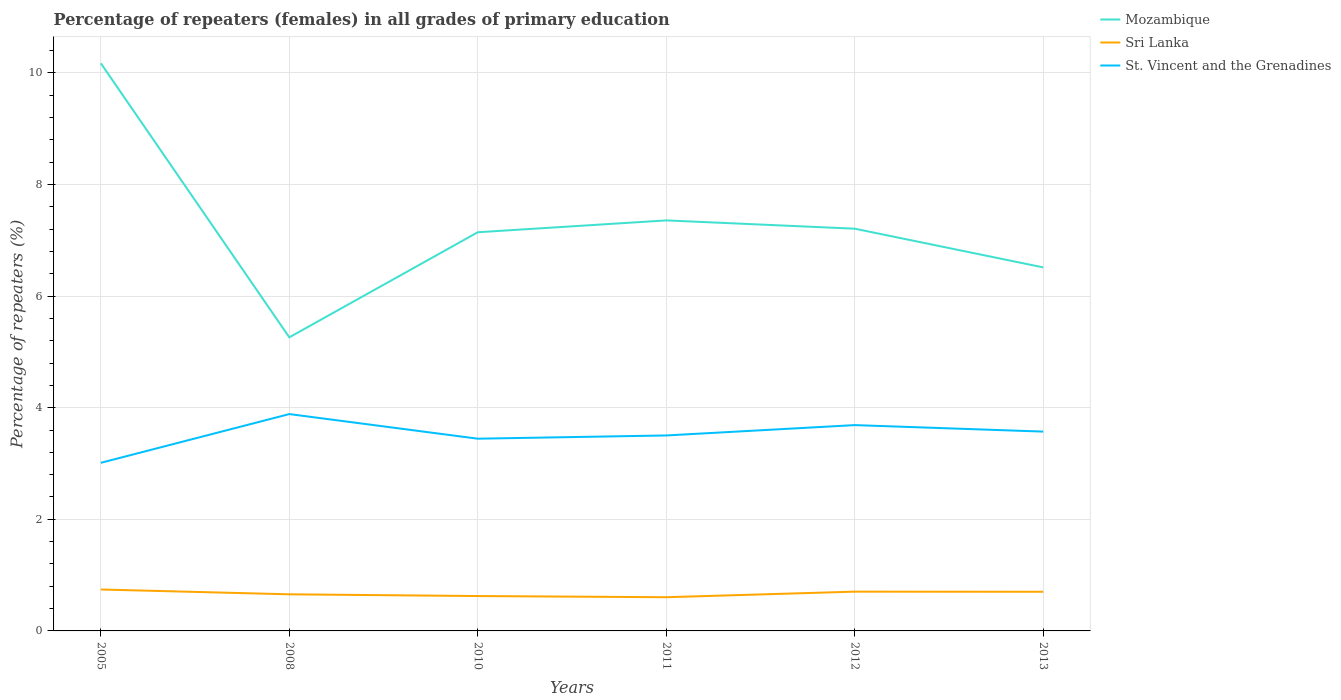How many different coloured lines are there?
Provide a succinct answer. 3. Is the number of lines equal to the number of legend labels?
Your answer should be very brief. Yes. Across all years, what is the maximum percentage of repeaters (females) in Mozambique?
Keep it short and to the point. 5.26. What is the total percentage of repeaters (females) in St. Vincent and the Grenadines in the graph?
Keep it short and to the point. -0.24. What is the difference between the highest and the second highest percentage of repeaters (females) in Mozambique?
Make the answer very short. 4.91. What is the difference between the highest and the lowest percentage of repeaters (females) in Sri Lanka?
Provide a short and direct response. 3. How many lines are there?
Make the answer very short. 3. What is the difference between two consecutive major ticks on the Y-axis?
Your answer should be compact. 2. Does the graph contain any zero values?
Keep it short and to the point. No. Does the graph contain grids?
Keep it short and to the point. Yes. Where does the legend appear in the graph?
Give a very brief answer. Top right. How many legend labels are there?
Your response must be concise. 3. What is the title of the graph?
Ensure brevity in your answer.  Percentage of repeaters (females) in all grades of primary education. Does "Belize" appear as one of the legend labels in the graph?
Make the answer very short. No. What is the label or title of the Y-axis?
Your answer should be compact. Percentage of repeaters (%). What is the Percentage of repeaters (%) of Mozambique in 2005?
Your answer should be compact. 10.17. What is the Percentage of repeaters (%) of Sri Lanka in 2005?
Keep it short and to the point. 0.74. What is the Percentage of repeaters (%) of St. Vincent and the Grenadines in 2005?
Your answer should be very brief. 3.01. What is the Percentage of repeaters (%) of Mozambique in 2008?
Offer a very short reply. 5.26. What is the Percentage of repeaters (%) of Sri Lanka in 2008?
Your answer should be compact. 0.66. What is the Percentage of repeaters (%) of St. Vincent and the Grenadines in 2008?
Provide a succinct answer. 3.89. What is the Percentage of repeaters (%) of Mozambique in 2010?
Keep it short and to the point. 7.14. What is the Percentage of repeaters (%) in Sri Lanka in 2010?
Keep it short and to the point. 0.63. What is the Percentage of repeaters (%) in St. Vincent and the Grenadines in 2010?
Your response must be concise. 3.44. What is the Percentage of repeaters (%) of Mozambique in 2011?
Your answer should be compact. 7.36. What is the Percentage of repeaters (%) of Sri Lanka in 2011?
Provide a succinct answer. 0.6. What is the Percentage of repeaters (%) in St. Vincent and the Grenadines in 2011?
Provide a short and direct response. 3.5. What is the Percentage of repeaters (%) of Mozambique in 2012?
Offer a very short reply. 7.21. What is the Percentage of repeaters (%) in Sri Lanka in 2012?
Make the answer very short. 0.7. What is the Percentage of repeaters (%) of St. Vincent and the Grenadines in 2012?
Ensure brevity in your answer.  3.69. What is the Percentage of repeaters (%) of Mozambique in 2013?
Give a very brief answer. 6.51. What is the Percentage of repeaters (%) in Sri Lanka in 2013?
Offer a terse response. 0.7. What is the Percentage of repeaters (%) of St. Vincent and the Grenadines in 2013?
Your response must be concise. 3.57. Across all years, what is the maximum Percentage of repeaters (%) in Mozambique?
Ensure brevity in your answer.  10.17. Across all years, what is the maximum Percentage of repeaters (%) in Sri Lanka?
Keep it short and to the point. 0.74. Across all years, what is the maximum Percentage of repeaters (%) in St. Vincent and the Grenadines?
Give a very brief answer. 3.89. Across all years, what is the minimum Percentage of repeaters (%) in Mozambique?
Give a very brief answer. 5.26. Across all years, what is the minimum Percentage of repeaters (%) of Sri Lanka?
Offer a very short reply. 0.6. Across all years, what is the minimum Percentage of repeaters (%) in St. Vincent and the Grenadines?
Provide a succinct answer. 3.01. What is the total Percentage of repeaters (%) in Mozambique in the graph?
Provide a succinct answer. 43.66. What is the total Percentage of repeaters (%) of Sri Lanka in the graph?
Your answer should be very brief. 4.03. What is the total Percentage of repeaters (%) in St. Vincent and the Grenadines in the graph?
Provide a short and direct response. 21.11. What is the difference between the Percentage of repeaters (%) of Mozambique in 2005 and that in 2008?
Keep it short and to the point. 4.91. What is the difference between the Percentage of repeaters (%) of Sri Lanka in 2005 and that in 2008?
Keep it short and to the point. 0.09. What is the difference between the Percentage of repeaters (%) in St. Vincent and the Grenadines in 2005 and that in 2008?
Ensure brevity in your answer.  -0.87. What is the difference between the Percentage of repeaters (%) in Mozambique in 2005 and that in 2010?
Your response must be concise. 3.03. What is the difference between the Percentage of repeaters (%) in Sri Lanka in 2005 and that in 2010?
Your answer should be very brief. 0.12. What is the difference between the Percentage of repeaters (%) in St. Vincent and the Grenadines in 2005 and that in 2010?
Provide a succinct answer. -0.43. What is the difference between the Percentage of repeaters (%) of Mozambique in 2005 and that in 2011?
Your answer should be compact. 2.82. What is the difference between the Percentage of repeaters (%) in Sri Lanka in 2005 and that in 2011?
Your answer should be compact. 0.14. What is the difference between the Percentage of repeaters (%) of St. Vincent and the Grenadines in 2005 and that in 2011?
Offer a terse response. -0.49. What is the difference between the Percentage of repeaters (%) in Mozambique in 2005 and that in 2012?
Provide a short and direct response. 2.96. What is the difference between the Percentage of repeaters (%) of Sri Lanka in 2005 and that in 2012?
Your answer should be compact. 0.04. What is the difference between the Percentage of repeaters (%) in St. Vincent and the Grenadines in 2005 and that in 2012?
Your response must be concise. -0.68. What is the difference between the Percentage of repeaters (%) in Mozambique in 2005 and that in 2013?
Make the answer very short. 3.66. What is the difference between the Percentage of repeaters (%) of Sri Lanka in 2005 and that in 2013?
Give a very brief answer. 0.04. What is the difference between the Percentage of repeaters (%) of St. Vincent and the Grenadines in 2005 and that in 2013?
Your answer should be compact. -0.56. What is the difference between the Percentage of repeaters (%) of Mozambique in 2008 and that in 2010?
Offer a very short reply. -1.88. What is the difference between the Percentage of repeaters (%) of Sri Lanka in 2008 and that in 2010?
Make the answer very short. 0.03. What is the difference between the Percentage of repeaters (%) in St. Vincent and the Grenadines in 2008 and that in 2010?
Offer a very short reply. 0.44. What is the difference between the Percentage of repeaters (%) of Mozambique in 2008 and that in 2011?
Give a very brief answer. -2.1. What is the difference between the Percentage of repeaters (%) in Sri Lanka in 2008 and that in 2011?
Your answer should be very brief. 0.05. What is the difference between the Percentage of repeaters (%) of St. Vincent and the Grenadines in 2008 and that in 2011?
Your response must be concise. 0.38. What is the difference between the Percentage of repeaters (%) of Mozambique in 2008 and that in 2012?
Give a very brief answer. -1.95. What is the difference between the Percentage of repeaters (%) of Sri Lanka in 2008 and that in 2012?
Your answer should be compact. -0.05. What is the difference between the Percentage of repeaters (%) in St. Vincent and the Grenadines in 2008 and that in 2012?
Offer a terse response. 0.2. What is the difference between the Percentage of repeaters (%) in Mozambique in 2008 and that in 2013?
Offer a terse response. -1.25. What is the difference between the Percentage of repeaters (%) of Sri Lanka in 2008 and that in 2013?
Offer a very short reply. -0.05. What is the difference between the Percentage of repeaters (%) in St. Vincent and the Grenadines in 2008 and that in 2013?
Your response must be concise. 0.31. What is the difference between the Percentage of repeaters (%) in Mozambique in 2010 and that in 2011?
Offer a very short reply. -0.21. What is the difference between the Percentage of repeaters (%) of Sri Lanka in 2010 and that in 2011?
Keep it short and to the point. 0.02. What is the difference between the Percentage of repeaters (%) in St. Vincent and the Grenadines in 2010 and that in 2011?
Your answer should be compact. -0.06. What is the difference between the Percentage of repeaters (%) in Mozambique in 2010 and that in 2012?
Your response must be concise. -0.06. What is the difference between the Percentage of repeaters (%) of Sri Lanka in 2010 and that in 2012?
Give a very brief answer. -0.08. What is the difference between the Percentage of repeaters (%) of St. Vincent and the Grenadines in 2010 and that in 2012?
Provide a short and direct response. -0.24. What is the difference between the Percentage of repeaters (%) in Mozambique in 2010 and that in 2013?
Give a very brief answer. 0.63. What is the difference between the Percentage of repeaters (%) of Sri Lanka in 2010 and that in 2013?
Ensure brevity in your answer.  -0.08. What is the difference between the Percentage of repeaters (%) of St. Vincent and the Grenadines in 2010 and that in 2013?
Offer a very short reply. -0.13. What is the difference between the Percentage of repeaters (%) in Mozambique in 2011 and that in 2012?
Make the answer very short. 0.15. What is the difference between the Percentage of repeaters (%) in Sri Lanka in 2011 and that in 2012?
Your response must be concise. -0.1. What is the difference between the Percentage of repeaters (%) of St. Vincent and the Grenadines in 2011 and that in 2012?
Provide a succinct answer. -0.19. What is the difference between the Percentage of repeaters (%) in Mozambique in 2011 and that in 2013?
Keep it short and to the point. 0.84. What is the difference between the Percentage of repeaters (%) in Sri Lanka in 2011 and that in 2013?
Offer a terse response. -0.1. What is the difference between the Percentage of repeaters (%) of St. Vincent and the Grenadines in 2011 and that in 2013?
Your answer should be very brief. -0.07. What is the difference between the Percentage of repeaters (%) of Mozambique in 2012 and that in 2013?
Your answer should be compact. 0.69. What is the difference between the Percentage of repeaters (%) of Sri Lanka in 2012 and that in 2013?
Your answer should be compact. 0. What is the difference between the Percentage of repeaters (%) of St. Vincent and the Grenadines in 2012 and that in 2013?
Your answer should be very brief. 0.12. What is the difference between the Percentage of repeaters (%) of Mozambique in 2005 and the Percentage of repeaters (%) of Sri Lanka in 2008?
Your answer should be compact. 9.52. What is the difference between the Percentage of repeaters (%) of Mozambique in 2005 and the Percentage of repeaters (%) of St. Vincent and the Grenadines in 2008?
Offer a terse response. 6.29. What is the difference between the Percentage of repeaters (%) of Sri Lanka in 2005 and the Percentage of repeaters (%) of St. Vincent and the Grenadines in 2008?
Your response must be concise. -3.14. What is the difference between the Percentage of repeaters (%) in Mozambique in 2005 and the Percentage of repeaters (%) in Sri Lanka in 2010?
Provide a short and direct response. 9.55. What is the difference between the Percentage of repeaters (%) of Mozambique in 2005 and the Percentage of repeaters (%) of St. Vincent and the Grenadines in 2010?
Your response must be concise. 6.73. What is the difference between the Percentage of repeaters (%) of Sri Lanka in 2005 and the Percentage of repeaters (%) of St. Vincent and the Grenadines in 2010?
Your answer should be compact. -2.7. What is the difference between the Percentage of repeaters (%) of Mozambique in 2005 and the Percentage of repeaters (%) of Sri Lanka in 2011?
Provide a succinct answer. 9.57. What is the difference between the Percentage of repeaters (%) of Mozambique in 2005 and the Percentage of repeaters (%) of St. Vincent and the Grenadines in 2011?
Your answer should be compact. 6.67. What is the difference between the Percentage of repeaters (%) in Sri Lanka in 2005 and the Percentage of repeaters (%) in St. Vincent and the Grenadines in 2011?
Make the answer very short. -2.76. What is the difference between the Percentage of repeaters (%) in Mozambique in 2005 and the Percentage of repeaters (%) in Sri Lanka in 2012?
Offer a very short reply. 9.47. What is the difference between the Percentage of repeaters (%) of Mozambique in 2005 and the Percentage of repeaters (%) of St. Vincent and the Grenadines in 2012?
Your answer should be very brief. 6.48. What is the difference between the Percentage of repeaters (%) in Sri Lanka in 2005 and the Percentage of repeaters (%) in St. Vincent and the Grenadines in 2012?
Give a very brief answer. -2.95. What is the difference between the Percentage of repeaters (%) in Mozambique in 2005 and the Percentage of repeaters (%) in Sri Lanka in 2013?
Provide a succinct answer. 9.47. What is the difference between the Percentage of repeaters (%) in Mozambique in 2005 and the Percentage of repeaters (%) in St. Vincent and the Grenadines in 2013?
Keep it short and to the point. 6.6. What is the difference between the Percentage of repeaters (%) of Sri Lanka in 2005 and the Percentage of repeaters (%) of St. Vincent and the Grenadines in 2013?
Make the answer very short. -2.83. What is the difference between the Percentage of repeaters (%) of Mozambique in 2008 and the Percentage of repeaters (%) of Sri Lanka in 2010?
Ensure brevity in your answer.  4.64. What is the difference between the Percentage of repeaters (%) in Mozambique in 2008 and the Percentage of repeaters (%) in St. Vincent and the Grenadines in 2010?
Your answer should be very brief. 1.82. What is the difference between the Percentage of repeaters (%) of Sri Lanka in 2008 and the Percentage of repeaters (%) of St. Vincent and the Grenadines in 2010?
Give a very brief answer. -2.79. What is the difference between the Percentage of repeaters (%) of Mozambique in 2008 and the Percentage of repeaters (%) of Sri Lanka in 2011?
Offer a terse response. 4.66. What is the difference between the Percentage of repeaters (%) in Mozambique in 2008 and the Percentage of repeaters (%) in St. Vincent and the Grenadines in 2011?
Make the answer very short. 1.76. What is the difference between the Percentage of repeaters (%) of Sri Lanka in 2008 and the Percentage of repeaters (%) of St. Vincent and the Grenadines in 2011?
Your answer should be compact. -2.85. What is the difference between the Percentage of repeaters (%) of Mozambique in 2008 and the Percentage of repeaters (%) of Sri Lanka in 2012?
Your response must be concise. 4.56. What is the difference between the Percentage of repeaters (%) of Mozambique in 2008 and the Percentage of repeaters (%) of St. Vincent and the Grenadines in 2012?
Your answer should be very brief. 1.57. What is the difference between the Percentage of repeaters (%) in Sri Lanka in 2008 and the Percentage of repeaters (%) in St. Vincent and the Grenadines in 2012?
Make the answer very short. -3.03. What is the difference between the Percentage of repeaters (%) in Mozambique in 2008 and the Percentage of repeaters (%) in Sri Lanka in 2013?
Your response must be concise. 4.56. What is the difference between the Percentage of repeaters (%) in Mozambique in 2008 and the Percentage of repeaters (%) in St. Vincent and the Grenadines in 2013?
Your response must be concise. 1.69. What is the difference between the Percentage of repeaters (%) in Sri Lanka in 2008 and the Percentage of repeaters (%) in St. Vincent and the Grenadines in 2013?
Give a very brief answer. -2.92. What is the difference between the Percentage of repeaters (%) in Mozambique in 2010 and the Percentage of repeaters (%) in Sri Lanka in 2011?
Ensure brevity in your answer.  6.54. What is the difference between the Percentage of repeaters (%) of Mozambique in 2010 and the Percentage of repeaters (%) of St. Vincent and the Grenadines in 2011?
Your answer should be compact. 3.64. What is the difference between the Percentage of repeaters (%) of Sri Lanka in 2010 and the Percentage of repeaters (%) of St. Vincent and the Grenadines in 2011?
Your answer should be compact. -2.88. What is the difference between the Percentage of repeaters (%) in Mozambique in 2010 and the Percentage of repeaters (%) in Sri Lanka in 2012?
Keep it short and to the point. 6.44. What is the difference between the Percentage of repeaters (%) of Mozambique in 2010 and the Percentage of repeaters (%) of St. Vincent and the Grenadines in 2012?
Make the answer very short. 3.46. What is the difference between the Percentage of repeaters (%) of Sri Lanka in 2010 and the Percentage of repeaters (%) of St. Vincent and the Grenadines in 2012?
Provide a short and direct response. -3.06. What is the difference between the Percentage of repeaters (%) in Mozambique in 2010 and the Percentage of repeaters (%) in Sri Lanka in 2013?
Provide a succinct answer. 6.44. What is the difference between the Percentage of repeaters (%) of Mozambique in 2010 and the Percentage of repeaters (%) of St. Vincent and the Grenadines in 2013?
Your response must be concise. 3.57. What is the difference between the Percentage of repeaters (%) of Sri Lanka in 2010 and the Percentage of repeaters (%) of St. Vincent and the Grenadines in 2013?
Give a very brief answer. -2.95. What is the difference between the Percentage of repeaters (%) of Mozambique in 2011 and the Percentage of repeaters (%) of Sri Lanka in 2012?
Make the answer very short. 6.65. What is the difference between the Percentage of repeaters (%) in Mozambique in 2011 and the Percentage of repeaters (%) in St. Vincent and the Grenadines in 2012?
Provide a short and direct response. 3.67. What is the difference between the Percentage of repeaters (%) in Sri Lanka in 2011 and the Percentage of repeaters (%) in St. Vincent and the Grenadines in 2012?
Make the answer very short. -3.08. What is the difference between the Percentage of repeaters (%) of Mozambique in 2011 and the Percentage of repeaters (%) of Sri Lanka in 2013?
Make the answer very short. 6.65. What is the difference between the Percentage of repeaters (%) of Mozambique in 2011 and the Percentage of repeaters (%) of St. Vincent and the Grenadines in 2013?
Provide a short and direct response. 3.78. What is the difference between the Percentage of repeaters (%) of Sri Lanka in 2011 and the Percentage of repeaters (%) of St. Vincent and the Grenadines in 2013?
Offer a terse response. -2.97. What is the difference between the Percentage of repeaters (%) of Mozambique in 2012 and the Percentage of repeaters (%) of Sri Lanka in 2013?
Keep it short and to the point. 6.51. What is the difference between the Percentage of repeaters (%) in Mozambique in 2012 and the Percentage of repeaters (%) in St. Vincent and the Grenadines in 2013?
Your response must be concise. 3.64. What is the difference between the Percentage of repeaters (%) in Sri Lanka in 2012 and the Percentage of repeaters (%) in St. Vincent and the Grenadines in 2013?
Give a very brief answer. -2.87. What is the average Percentage of repeaters (%) of Mozambique per year?
Ensure brevity in your answer.  7.28. What is the average Percentage of repeaters (%) in Sri Lanka per year?
Your response must be concise. 0.67. What is the average Percentage of repeaters (%) of St. Vincent and the Grenadines per year?
Provide a succinct answer. 3.52. In the year 2005, what is the difference between the Percentage of repeaters (%) of Mozambique and Percentage of repeaters (%) of Sri Lanka?
Give a very brief answer. 9.43. In the year 2005, what is the difference between the Percentage of repeaters (%) in Mozambique and Percentage of repeaters (%) in St. Vincent and the Grenadines?
Provide a succinct answer. 7.16. In the year 2005, what is the difference between the Percentage of repeaters (%) in Sri Lanka and Percentage of repeaters (%) in St. Vincent and the Grenadines?
Your response must be concise. -2.27. In the year 2008, what is the difference between the Percentage of repeaters (%) in Mozambique and Percentage of repeaters (%) in Sri Lanka?
Your answer should be compact. 4.61. In the year 2008, what is the difference between the Percentage of repeaters (%) in Mozambique and Percentage of repeaters (%) in St. Vincent and the Grenadines?
Provide a short and direct response. 1.38. In the year 2008, what is the difference between the Percentage of repeaters (%) of Sri Lanka and Percentage of repeaters (%) of St. Vincent and the Grenadines?
Keep it short and to the point. -3.23. In the year 2010, what is the difference between the Percentage of repeaters (%) in Mozambique and Percentage of repeaters (%) in Sri Lanka?
Your response must be concise. 6.52. In the year 2010, what is the difference between the Percentage of repeaters (%) of Mozambique and Percentage of repeaters (%) of St. Vincent and the Grenadines?
Your answer should be compact. 3.7. In the year 2010, what is the difference between the Percentage of repeaters (%) in Sri Lanka and Percentage of repeaters (%) in St. Vincent and the Grenadines?
Provide a succinct answer. -2.82. In the year 2011, what is the difference between the Percentage of repeaters (%) of Mozambique and Percentage of repeaters (%) of Sri Lanka?
Your answer should be very brief. 6.75. In the year 2011, what is the difference between the Percentage of repeaters (%) of Mozambique and Percentage of repeaters (%) of St. Vincent and the Grenadines?
Your answer should be very brief. 3.85. In the year 2011, what is the difference between the Percentage of repeaters (%) of Sri Lanka and Percentage of repeaters (%) of St. Vincent and the Grenadines?
Give a very brief answer. -2.9. In the year 2012, what is the difference between the Percentage of repeaters (%) of Mozambique and Percentage of repeaters (%) of Sri Lanka?
Provide a succinct answer. 6.5. In the year 2012, what is the difference between the Percentage of repeaters (%) of Mozambique and Percentage of repeaters (%) of St. Vincent and the Grenadines?
Provide a succinct answer. 3.52. In the year 2012, what is the difference between the Percentage of repeaters (%) of Sri Lanka and Percentage of repeaters (%) of St. Vincent and the Grenadines?
Your answer should be very brief. -2.98. In the year 2013, what is the difference between the Percentage of repeaters (%) in Mozambique and Percentage of repeaters (%) in Sri Lanka?
Offer a very short reply. 5.81. In the year 2013, what is the difference between the Percentage of repeaters (%) in Mozambique and Percentage of repeaters (%) in St. Vincent and the Grenadines?
Give a very brief answer. 2.94. In the year 2013, what is the difference between the Percentage of repeaters (%) in Sri Lanka and Percentage of repeaters (%) in St. Vincent and the Grenadines?
Keep it short and to the point. -2.87. What is the ratio of the Percentage of repeaters (%) in Mozambique in 2005 to that in 2008?
Your answer should be very brief. 1.93. What is the ratio of the Percentage of repeaters (%) in Sri Lanka in 2005 to that in 2008?
Provide a succinct answer. 1.13. What is the ratio of the Percentage of repeaters (%) in St. Vincent and the Grenadines in 2005 to that in 2008?
Offer a terse response. 0.78. What is the ratio of the Percentage of repeaters (%) of Mozambique in 2005 to that in 2010?
Your answer should be very brief. 1.42. What is the ratio of the Percentage of repeaters (%) in Sri Lanka in 2005 to that in 2010?
Make the answer very short. 1.19. What is the ratio of the Percentage of repeaters (%) of St. Vincent and the Grenadines in 2005 to that in 2010?
Make the answer very short. 0.87. What is the ratio of the Percentage of repeaters (%) in Mozambique in 2005 to that in 2011?
Ensure brevity in your answer.  1.38. What is the ratio of the Percentage of repeaters (%) of Sri Lanka in 2005 to that in 2011?
Give a very brief answer. 1.23. What is the ratio of the Percentage of repeaters (%) in St. Vincent and the Grenadines in 2005 to that in 2011?
Your answer should be very brief. 0.86. What is the ratio of the Percentage of repeaters (%) in Mozambique in 2005 to that in 2012?
Your response must be concise. 1.41. What is the ratio of the Percentage of repeaters (%) of Sri Lanka in 2005 to that in 2012?
Offer a very short reply. 1.05. What is the ratio of the Percentage of repeaters (%) in St. Vincent and the Grenadines in 2005 to that in 2012?
Ensure brevity in your answer.  0.82. What is the ratio of the Percentage of repeaters (%) in Mozambique in 2005 to that in 2013?
Your answer should be compact. 1.56. What is the ratio of the Percentage of repeaters (%) of Sri Lanka in 2005 to that in 2013?
Give a very brief answer. 1.06. What is the ratio of the Percentage of repeaters (%) in St. Vincent and the Grenadines in 2005 to that in 2013?
Provide a succinct answer. 0.84. What is the ratio of the Percentage of repeaters (%) in Mozambique in 2008 to that in 2010?
Keep it short and to the point. 0.74. What is the ratio of the Percentage of repeaters (%) in Sri Lanka in 2008 to that in 2010?
Provide a short and direct response. 1.05. What is the ratio of the Percentage of repeaters (%) of St. Vincent and the Grenadines in 2008 to that in 2010?
Make the answer very short. 1.13. What is the ratio of the Percentage of repeaters (%) of Mozambique in 2008 to that in 2011?
Provide a succinct answer. 0.72. What is the ratio of the Percentage of repeaters (%) in Sri Lanka in 2008 to that in 2011?
Offer a very short reply. 1.09. What is the ratio of the Percentage of repeaters (%) in St. Vincent and the Grenadines in 2008 to that in 2011?
Provide a short and direct response. 1.11. What is the ratio of the Percentage of repeaters (%) of Mozambique in 2008 to that in 2012?
Keep it short and to the point. 0.73. What is the ratio of the Percentage of repeaters (%) in Sri Lanka in 2008 to that in 2012?
Keep it short and to the point. 0.93. What is the ratio of the Percentage of repeaters (%) in St. Vincent and the Grenadines in 2008 to that in 2012?
Offer a terse response. 1.05. What is the ratio of the Percentage of repeaters (%) of Mozambique in 2008 to that in 2013?
Your answer should be very brief. 0.81. What is the ratio of the Percentage of repeaters (%) of Sri Lanka in 2008 to that in 2013?
Your answer should be compact. 0.93. What is the ratio of the Percentage of repeaters (%) of St. Vincent and the Grenadines in 2008 to that in 2013?
Your response must be concise. 1.09. What is the ratio of the Percentage of repeaters (%) of Mozambique in 2010 to that in 2011?
Keep it short and to the point. 0.97. What is the ratio of the Percentage of repeaters (%) in Sri Lanka in 2010 to that in 2011?
Your answer should be very brief. 1.03. What is the ratio of the Percentage of repeaters (%) in St. Vincent and the Grenadines in 2010 to that in 2011?
Your response must be concise. 0.98. What is the ratio of the Percentage of repeaters (%) in Mozambique in 2010 to that in 2012?
Offer a terse response. 0.99. What is the ratio of the Percentage of repeaters (%) of Sri Lanka in 2010 to that in 2012?
Provide a succinct answer. 0.89. What is the ratio of the Percentage of repeaters (%) of St. Vincent and the Grenadines in 2010 to that in 2012?
Provide a short and direct response. 0.93. What is the ratio of the Percentage of repeaters (%) in Mozambique in 2010 to that in 2013?
Your response must be concise. 1.1. What is the ratio of the Percentage of repeaters (%) of Sri Lanka in 2010 to that in 2013?
Offer a very short reply. 0.89. What is the ratio of the Percentage of repeaters (%) of St. Vincent and the Grenadines in 2010 to that in 2013?
Give a very brief answer. 0.96. What is the ratio of the Percentage of repeaters (%) of Mozambique in 2011 to that in 2012?
Your answer should be very brief. 1.02. What is the ratio of the Percentage of repeaters (%) in Sri Lanka in 2011 to that in 2012?
Your response must be concise. 0.86. What is the ratio of the Percentage of repeaters (%) in St. Vincent and the Grenadines in 2011 to that in 2012?
Offer a very short reply. 0.95. What is the ratio of the Percentage of repeaters (%) of Mozambique in 2011 to that in 2013?
Provide a short and direct response. 1.13. What is the ratio of the Percentage of repeaters (%) in Sri Lanka in 2011 to that in 2013?
Your answer should be compact. 0.86. What is the ratio of the Percentage of repeaters (%) in St. Vincent and the Grenadines in 2011 to that in 2013?
Provide a short and direct response. 0.98. What is the ratio of the Percentage of repeaters (%) of Mozambique in 2012 to that in 2013?
Provide a short and direct response. 1.11. What is the ratio of the Percentage of repeaters (%) of Sri Lanka in 2012 to that in 2013?
Keep it short and to the point. 1. What is the ratio of the Percentage of repeaters (%) in St. Vincent and the Grenadines in 2012 to that in 2013?
Offer a terse response. 1.03. What is the difference between the highest and the second highest Percentage of repeaters (%) in Mozambique?
Ensure brevity in your answer.  2.82. What is the difference between the highest and the second highest Percentage of repeaters (%) of Sri Lanka?
Offer a very short reply. 0.04. What is the difference between the highest and the second highest Percentage of repeaters (%) of St. Vincent and the Grenadines?
Give a very brief answer. 0.2. What is the difference between the highest and the lowest Percentage of repeaters (%) in Mozambique?
Offer a terse response. 4.91. What is the difference between the highest and the lowest Percentage of repeaters (%) of Sri Lanka?
Ensure brevity in your answer.  0.14. What is the difference between the highest and the lowest Percentage of repeaters (%) of St. Vincent and the Grenadines?
Your answer should be compact. 0.87. 